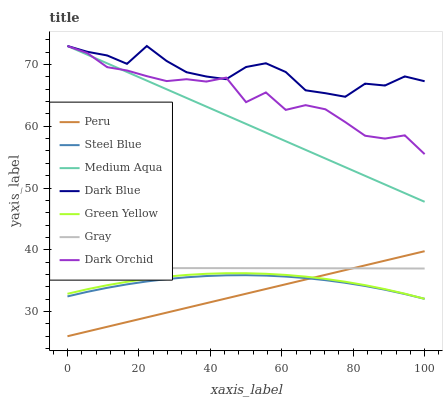Does Peru have the minimum area under the curve?
Answer yes or no. Yes. Does Dark Blue have the maximum area under the curve?
Answer yes or no. Yes. Does Steel Blue have the minimum area under the curve?
Answer yes or no. No. Does Steel Blue have the maximum area under the curve?
Answer yes or no. No. Is Peru the smoothest?
Answer yes or no. Yes. Is Dark Orchid the roughest?
Answer yes or no. Yes. Is Steel Blue the smoothest?
Answer yes or no. No. Is Steel Blue the roughest?
Answer yes or no. No. Does Peru have the lowest value?
Answer yes or no. Yes. Does Steel Blue have the lowest value?
Answer yes or no. No. Does Medium Aqua have the highest value?
Answer yes or no. Yes. Does Steel Blue have the highest value?
Answer yes or no. No. Is Steel Blue less than Green Yellow?
Answer yes or no. Yes. Is Medium Aqua greater than Steel Blue?
Answer yes or no. Yes. Does Peru intersect Steel Blue?
Answer yes or no. Yes. Is Peru less than Steel Blue?
Answer yes or no. No. Is Peru greater than Steel Blue?
Answer yes or no. No. Does Steel Blue intersect Green Yellow?
Answer yes or no. No. 